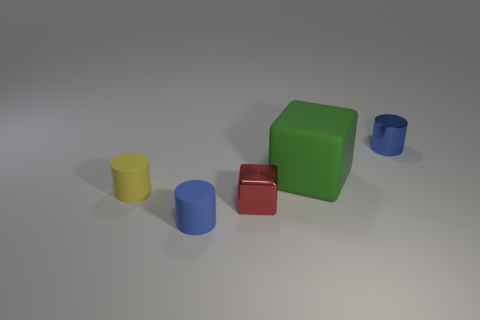The shiny cylinder is what color? The cylinder with the glossy surface in the image is blue. It stands out with its bright, saturated hue against the softer backdrop. 